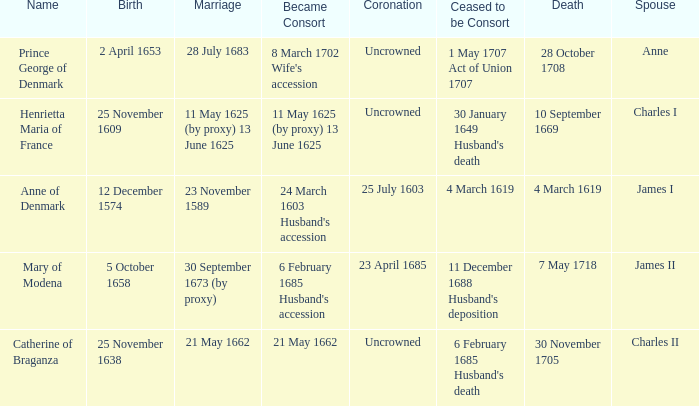On what date did James II take a consort? 6 February 1685 Husband's accession. 